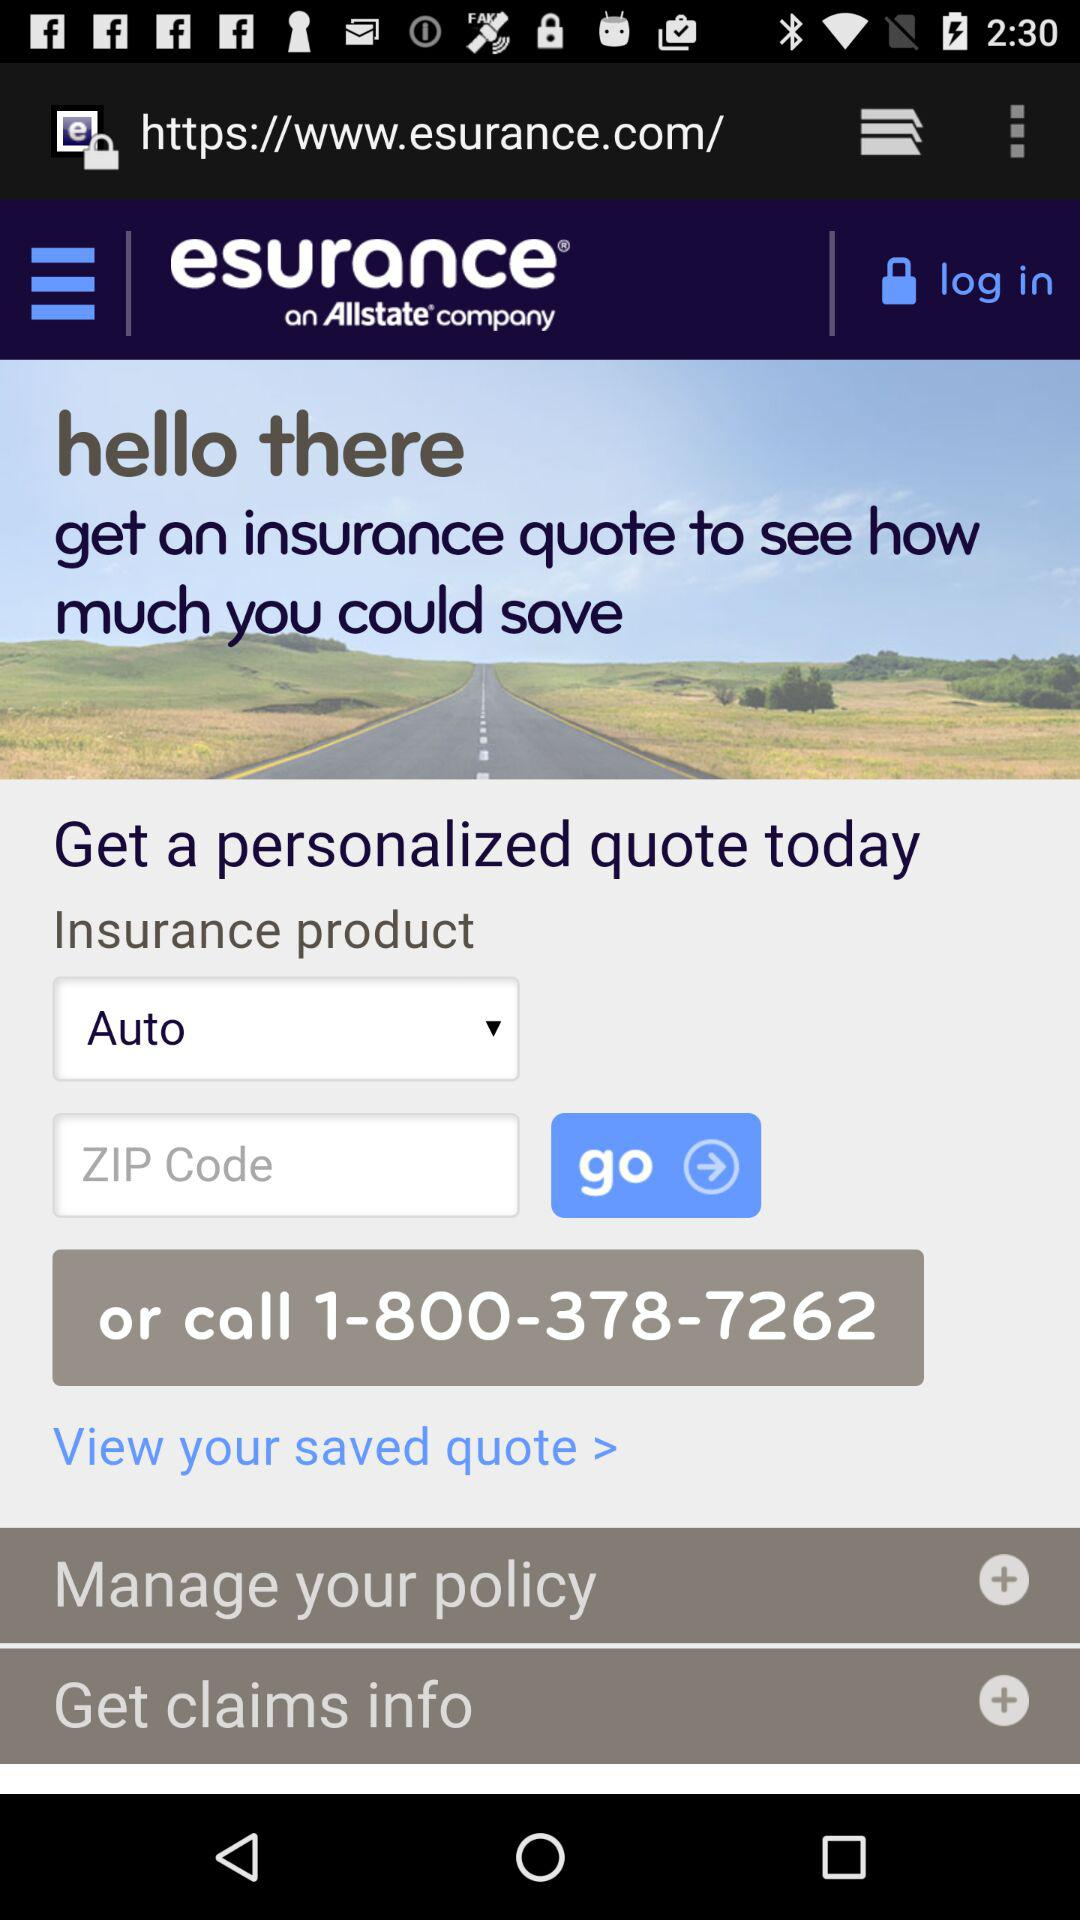What is the name of the application?
When the provided information is insufficient, respond with <no answer>. <no answer> 